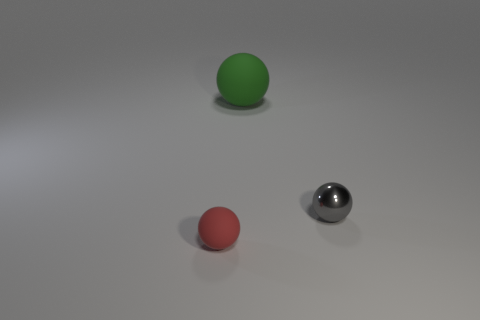There is a tiny object in front of the tiny gray ball right of the tiny red rubber sphere; what is it made of?
Give a very brief answer. Rubber. There is another shiny object that is the same shape as the green thing; what is its size?
Keep it short and to the point. Small. Is the color of the small object in front of the small metal sphere the same as the metal sphere?
Keep it short and to the point. No. Is the number of small gray spheres less than the number of yellow shiny cubes?
Your answer should be very brief. No. What number of other objects are there of the same color as the tiny rubber ball?
Your response must be concise. 0. Do the ball that is to the right of the big thing and the red sphere have the same material?
Provide a succinct answer. No. What is the material of the thing in front of the small gray metal object?
Make the answer very short. Rubber. There is a rubber thing that is behind the sphere that is on the left side of the big ball; what is its size?
Ensure brevity in your answer.  Large. Is there a big red ball made of the same material as the green thing?
Keep it short and to the point. No. There is a matte object in front of the tiny ball behind the small sphere in front of the tiny gray metallic ball; what is its shape?
Ensure brevity in your answer.  Sphere. 